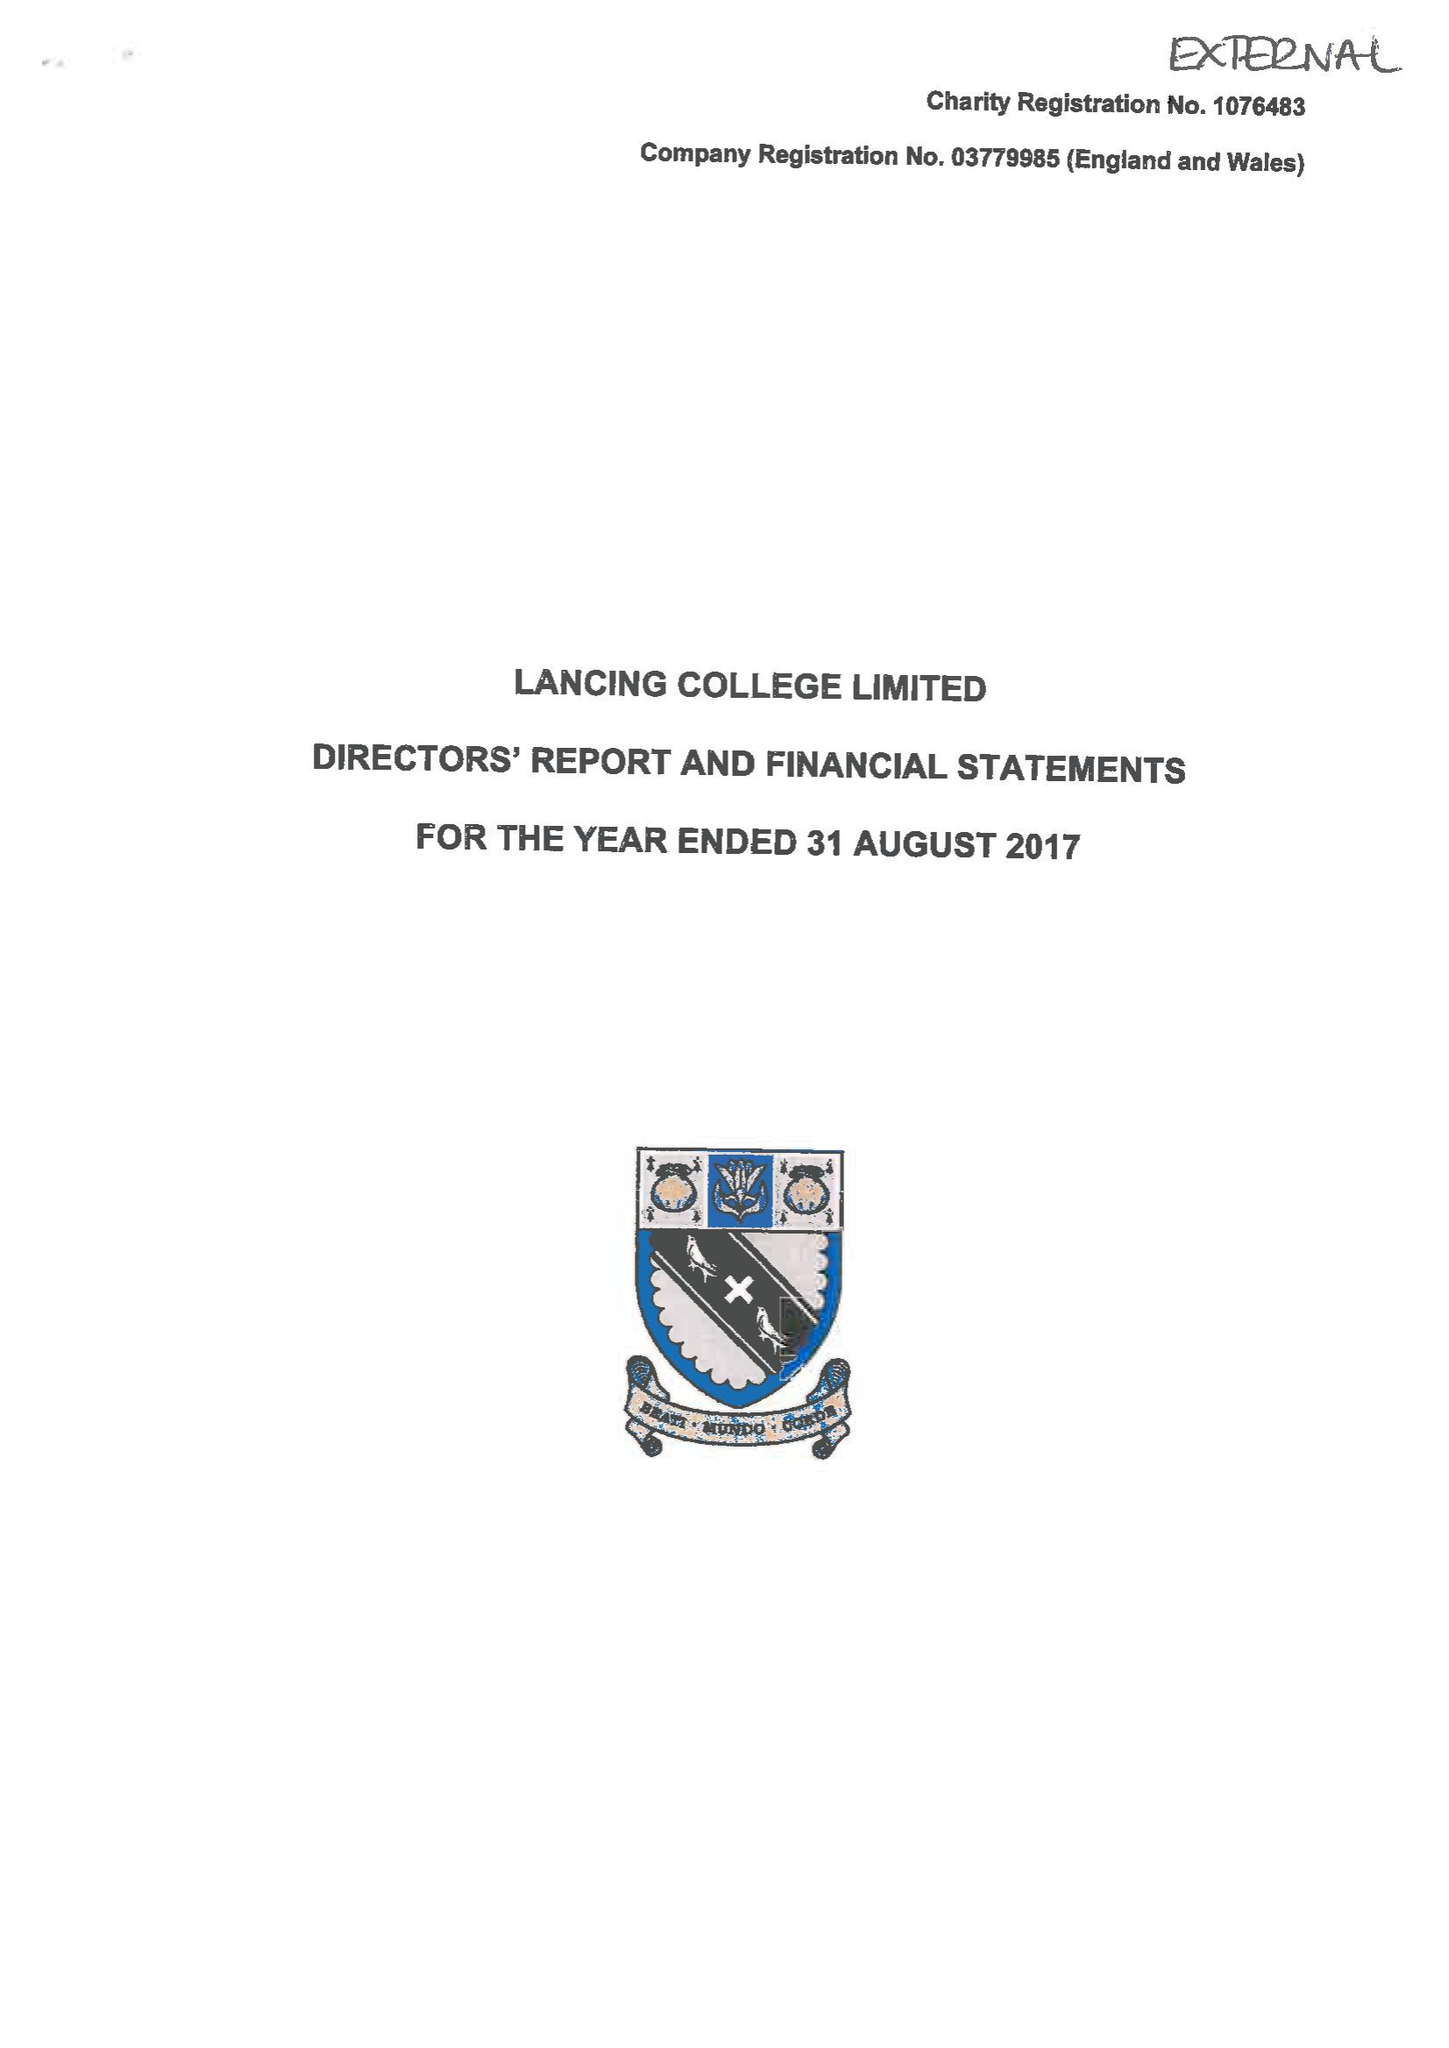What is the value for the address__post_town?
Answer the question using a single word or phrase. LANCING 